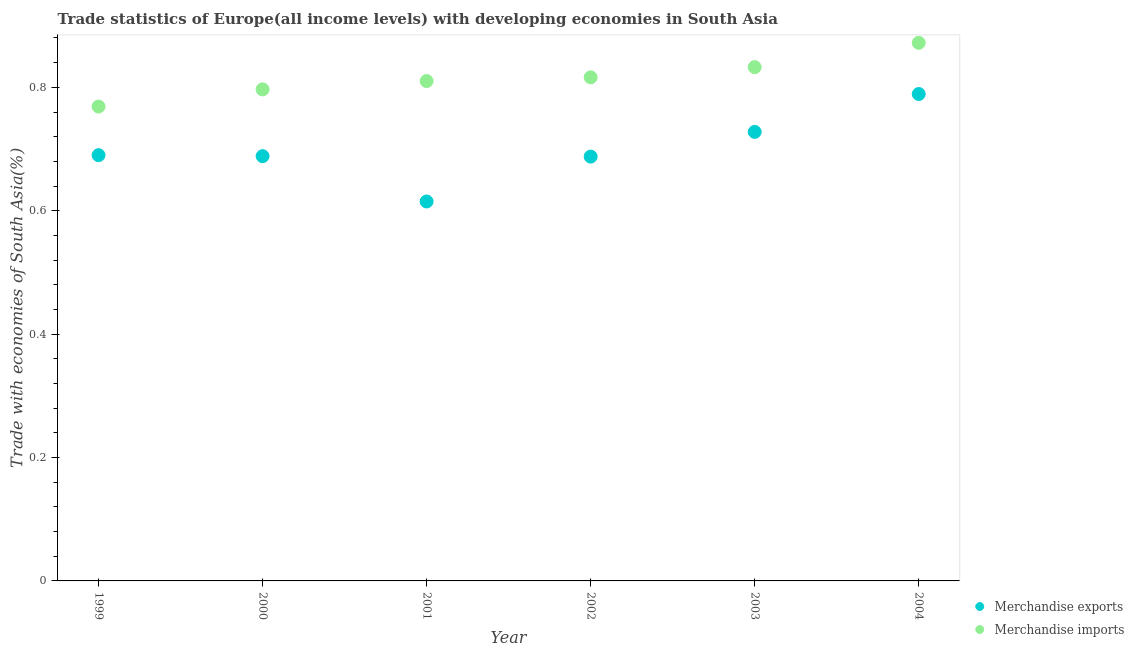How many different coloured dotlines are there?
Your response must be concise. 2. Is the number of dotlines equal to the number of legend labels?
Offer a very short reply. Yes. What is the merchandise imports in 2002?
Give a very brief answer. 0.82. Across all years, what is the maximum merchandise exports?
Offer a very short reply. 0.79. Across all years, what is the minimum merchandise imports?
Offer a very short reply. 0.77. In which year was the merchandise exports minimum?
Provide a short and direct response. 2001. What is the total merchandise exports in the graph?
Offer a terse response. 4.2. What is the difference between the merchandise imports in 1999 and that in 2004?
Make the answer very short. -0.1. What is the difference between the merchandise imports in 2002 and the merchandise exports in 2004?
Provide a succinct answer. 0.03. What is the average merchandise exports per year?
Make the answer very short. 0.7. In the year 2001, what is the difference between the merchandise imports and merchandise exports?
Give a very brief answer. 0.2. In how many years, is the merchandise imports greater than 0.12 %?
Provide a succinct answer. 6. What is the ratio of the merchandise imports in 2000 to that in 2001?
Provide a short and direct response. 0.98. Is the merchandise imports in 2000 less than that in 2003?
Make the answer very short. Yes. Is the difference between the merchandise exports in 1999 and 2003 greater than the difference between the merchandise imports in 1999 and 2003?
Keep it short and to the point. Yes. What is the difference between the highest and the second highest merchandise imports?
Your answer should be very brief. 0.04. What is the difference between the highest and the lowest merchandise exports?
Your answer should be very brief. 0.17. Is the sum of the merchandise exports in 1999 and 2001 greater than the maximum merchandise imports across all years?
Your response must be concise. Yes. Does the merchandise imports monotonically increase over the years?
Provide a short and direct response. Yes. How many years are there in the graph?
Your response must be concise. 6. Are the values on the major ticks of Y-axis written in scientific E-notation?
Your answer should be very brief. No. Does the graph contain any zero values?
Your answer should be compact. No. Does the graph contain grids?
Offer a terse response. No. How are the legend labels stacked?
Provide a succinct answer. Vertical. What is the title of the graph?
Offer a terse response. Trade statistics of Europe(all income levels) with developing economies in South Asia. Does "Boys" appear as one of the legend labels in the graph?
Keep it short and to the point. No. What is the label or title of the Y-axis?
Keep it short and to the point. Trade with economies of South Asia(%). What is the Trade with economies of South Asia(%) of Merchandise exports in 1999?
Provide a succinct answer. 0.69. What is the Trade with economies of South Asia(%) in Merchandise imports in 1999?
Make the answer very short. 0.77. What is the Trade with economies of South Asia(%) of Merchandise exports in 2000?
Give a very brief answer. 0.69. What is the Trade with economies of South Asia(%) in Merchandise imports in 2000?
Provide a short and direct response. 0.8. What is the Trade with economies of South Asia(%) in Merchandise exports in 2001?
Provide a short and direct response. 0.61. What is the Trade with economies of South Asia(%) of Merchandise imports in 2001?
Ensure brevity in your answer.  0.81. What is the Trade with economies of South Asia(%) of Merchandise exports in 2002?
Keep it short and to the point. 0.69. What is the Trade with economies of South Asia(%) of Merchandise imports in 2002?
Make the answer very short. 0.82. What is the Trade with economies of South Asia(%) in Merchandise exports in 2003?
Keep it short and to the point. 0.73. What is the Trade with economies of South Asia(%) of Merchandise imports in 2003?
Offer a terse response. 0.83. What is the Trade with economies of South Asia(%) in Merchandise exports in 2004?
Provide a succinct answer. 0.79. What is the Trade with economies of South Asia(%) in Merchandise imports in 2004?
Offer a very short reply. 0.87. Across all years, what is the maximum Trade with economies of South Asia(%) of Merchandise exports?
Make the answer very short. 0.79. Across all years, what is the maximum Trade with economies of South Asia(%) in Merchandise imports?
Your response must be concise. 0.87. Across all years, what is the minimum Trade with economies of South Asia(%) of Merchandise exports?
Make the answer very short. 0.61. Across all years, what is the minimum Trade with economies of South Asia(%) in Merchandise imports?
Offer a very short reply. 0.77. What is the total Trade with economies of South Asia(%) of Merchandise exports in the graph?
Your answer should be very brief. 4.2. What is the total Trade with economies of South Asia(%) in Merchandise imports in the graph?
Provide a short and direct response. 4.9. What is the difference between the Trade with economies of South Asia(%) of Merchandise exports in 1999 and that in 2000?
Keep it short and to the point. 0. What is the difference between the Trade with economies of South Asia(%) of Merchandise imports in 1999 and that in 2000?
Provide a succinct answer. -0.03. What is the difference between the Trade with economies of South Asia(%) of Merchandise exports in 1999 and that in 2001?
Give a very brief answer. 0.08. What is the difference between the Trade with economies of South Asia(%) of Merchandise imports in 1999 and that in 2001?
Offer a very short reply. -0.04. What is the difference between the Trade with economies of South Asia(%) in Merchandise exports in 1999 and that in 2002?
Provide a short and direct response. 0. What is the difference between the Trade with economies of South Asia(%) of Merchandise imports in 1999 and that in 2002?
Offer a terse response. -0.05. What is the difference between the Trade with economies of South Asia(%) of Merchandise exports in 1999 and that in 2003?
Keep it short and to the point. -0.04. What is the difference between the Trade with economies of South Asia(%) of Merchandise imports in 1999 and that in 2003?
Provide a succinct answer. -0.06. What is the difference between the Trade with economies of South Asia(%) in Merchandise exports in 1999 and that in 2004?
Your response must be concise. -0.1. What is the difference between the Trade with economies of South Asia(%) in Merchandise imports in 1999 and that in 2004?
Your response must be concise. -0.1. What is the difference between the Trade with economies of South Asia(%) in Merchandise exports in 2000 and that in 2001?
Make the answer very short. 0.07. What is the difference between the Trade with economies of South Asia(%) in Merchandise imports in 2000 and that in 2001?
Make the answer very short. -0.01. What is the difference between the Trade with economies of South Asia(%) of Merchandise exports in 2000 and that in 2002?
Make the answer very short. 0. What is the difference between the Trade with economies of South Asia(%) in Merchandise imports in 2000 and that in 2002?
Offer a very short reply. -0.02. What is the difference between the Trade with economies of South Asia(%) of Merchandise exports in 2000 and that in 2003?
Your response must be concise. -0.04. What is the difference between the Trade with economies of South Asia(%) in Merchandise imports in 2000 and that in 2003?
Provide a succinct answer. -0.04. What is the difference between the Trade with economies of South Asia(%) of Merchandise exports in 2000 and that in 2004?
Keep it short and to the point. -0.1. What is the difference between the Trade with economies of South Asia(%) in Merchandise imports in 2000 and that in 2004?
Offer a very short reply. -0.08. What is the difference between the Trade with economies of South Asia(%) in Merchandise exports in 2001 and that in 2002?
Provide a succinct answer. -0.07. What is the difference between the Trade with economies of South Asia(%) of Merchandise imports in 2001 and that in 2002?
Ensure brevity in your answer.  -0.01. What is the difference between the Trade with economies of South Asia(%) of Merchandise exports in 2001 and that in 2003?
Offer a terse response. -0.11. What is the difference between the Trade with economies of South Asia(%) of Merchandise imports in 2001 and that in 2003?
Your answer should be very brief. -0.02. What is the difference between the Trade with economies of South Asia(%) in Merchandise exports in 2001 and that in 2004?
Keep it short and to the point. -0.17. What is the difference between the Trade with economies of South Asia(%) of Merchandise imports in 2001 and that in 2004?
Keep it short and to the point. -0.06. What is the difference between the Trade with economies of South Asia(%) of Merchandise exports in 2002 and that in 2003?
Make the answer very short. -0.04. What is the difference between the Trade with economies of South Asia(%) of Merchandise imports in 2002 and that in 2003?
Provide a succinct answer. -0.02. What is the difference between the Trade with economies of South Asia(%) in Merchandise exports in 2002 and that in 2004?
Make the answer very short. -0.1. What is the difference between the Trade with economies of South Asia(%) in Merchandise imports in 2002 and that in 2004?
Your response must be concise. -0.06. What is the difference between the Trade with economies of South Asia(%) in Merchandise exports in 2003 and that in 2004?
Make the answer very short. -0.06. What is the difference between the Trade with economies of South Asia(%) in Merchandise imports in 2003 and that in 2004?
Your answer should be very brief. -0.04. What is the difference between the Trade with economies of South Asia(%) of Merchandise exports in 1999 and the Trade with economies of South Asia(%) of Merchandise imports in 2000?
Your answer should be very brief. -0.11. What is the difference between the Trade with economies of South Asia(%) in Merchandise exports in 1999 and the Trade with economies of South Asia(%) in Merchandise imports in 2001?
Provide a short and direct response. -0.12. What is the difference between the Trade with economies of South Asia(%) of Merchandise exports in 1999 and the Trade with economies of South Asia(%) of Merchandise imports in 2002?
Provide a short and direct response. -0.13. What is the difference between the Trade with economies of South Asia(%) of Merchandise exports in 1999 and the Trade with economies of South Asia(%) of Merchandise imports in 2003?
Offer a very short reply. -0.14. What is the difference between the Trade with economies of South Asia(%) in Merchandise exports in 1999 and the Trade with economies of South Asia(%) in Merchandise imports in 2004?
Make the answer very short. -0.18. What is the difference between the Trade with economies of South Asia(%) of Merchandise exports in 2000 and the Trade with economies of South Asia(%) of Merchandise imports in 2001?
Offer a terse response. -0.12. What is the difference between the Trade with economies of South Asia(%) in Merchandise exports in 2000 and the Trade with economies of South Asia(%) in Merchandise imports in 2002?
Offer a terse response. -0.13. What is the difference between the Trade with economies of South Asia(%) in Merchandise exports in 2000 and the Trade with economies of South Asia(%) in Merchandise imports in 2003?
Offer a very short reply. -0.14. What is the difference between the Trade with economies of South Asia(%) in Merchandise exports in 2000 and the Trade with economies of South Asia(%) in Merchandise imports in 2004?
Ensure brevity in your answer.  -0.18. What is the difference between the Trade with economies of South Asia(%) of Merchandise exports in 2001 and the Trade with economies of South Asia(%) of Merchandise imports in 2002?
Provide a short and direct response. -0.2. What is the difference between the Trade with economies of South Asia(%) of Merchandise exports in 2001 and the Trade with economies of South Asia(%) of Merchandise imports in 2003?
Offer a very short reply. -0.22. What is the difference between the Trade with economies of South Asia(%) of Merchandise exports in 2001 and the Trade with economies of South Asia(%) of Merchandise imports in 2004?
Your answer should be compact. -0.26. What is the difference between the Trade with economies of South Asia(%) of Merchandise exports in 2002 and the Trade with economies of South Asia(%) of Merchandise imports in 2003?
Your answer should be very brief. -0.14. What is the difference between the Trade with economies of South Asia(%) of Merchandise exports in 2002 and the Trade with economies of South Asia(%) of Merchandise imports in 2004?
Make the answer very short. -0.18. What is the difference between the Trade with economies of South Asia(%) in Merchandise exports in 2003 and the Trade with economies of South Asia(%) in Merchandise imports in 2004?
Offer a terse response. -0.14. What is the average Trade with economies of South Asia(%) of Merchandise exports per year?
Give a very brief answer. 0.7. What is the average Trade with economies of South Asia(%) in Merchandise imports per year?
Offer a very short reply. 0.82. In the year 1999, what is the difference between the Trade with economies of South Asia(%) of Merchandise exports and Trade with economies of South Asia(%) of Merchandise imports?
Ensure brevity in your answer.  -0.08. In the year 2000, what is the difference between the Trade with economies of South Asia(%) of Merchandise exports and Trade with economies of South Asia(%) of Merchandise imports?
Your response must be concise. -0.11. In the year 2001, what is the difference between the Trade with economies of South Asia(%) in Merchandise exports and Trade with economies of South Asia(%) in Merchandise imports?
Your answer should be compact. -0.2. In the year 2002, what is the difference between the Trade with economies of South Asia(%) of Merchandise exports and Trade with economies of South Asia(%) of Merchandise imports?
Offer a very short reply. -0.13. In the year 2003, what is the difference between the Trade with economies of South Asia(%) of Merchandise exports and Trade with economies of South Asia(%) of Merchandise imports?
Offer a terse response. -0.1. In the year 2004, what is the difference between the Trade with economies of South Asia(%) of Merchandise exports and Trade with economies of South Asia(%) of Merchandise imports?
Give a very brief answer. -0.08. What is the ratio of the Trade with economies of South Asia(%) of Merchandise imports in 1999 to that in 2000?
Provide a short and direct response. 0.97. What is the ratio of the Trade with economies of South Asia(%) in Merchandise exports in 1999 to that in 2001?
Ensure brevity in your answer.  1.12. What is the ratio of the Trade with economies of South Asia(%) of Merchandise imports in 1999 to that in 2001?
Offer a terse response. 0.95. What is the ratio of the Trade with economies of South Asia(%) in Merchandise imports in 1999 to that in 2002?
Your response must be concise. 0.94. What is the ratio of the Trade with economies of South Asia(%) of Merchandise exports in 1999 to that in 2003?
Your response must be concise. 0.95. What is the ratio of the Trade with economies of South Asia(%) of Merchandise imports in 1999 to that in 2003?
Make the answer very short. 0.92. What is the ratio of the Trade with economies of South Asia(%) of Merchandise exports in 1999 to that in 2004?
Provide a succinct answer. 0.87. What is the ratio of the Trade with economies of South Asia(%) of Merchandise imports in 1999 to that in 2004?
Provide a succinct answer. 0.88. What is the ratio of the Trade with economies of South Asia(%) of Merchandise exports in 2000 to that in 2001?
Your answer should be compact. 1.12. What is the ratio of the Trade with economies of South Asia(%) of Merchandise imports in 2000 to that in 2001?
Keep it short and to the point. 0.98. What is the ratio of the Trade with economies of South Asia(%) in Merchandise exports in 2000 to that in 2002?
Your response must be concise. 1. What is the ratio of the Trade with economies of South Asia(%) of Merchandise imports in 2000 to that in 2002?
Your response must be concise. 0.98. What is the ratio of the Trade with economies of South Asia(%) of Merchandise exports in 2000 to that in 2003?
Offer a very short reply. 0.95. What is the ratio of the Trade with economies of South Asia(%) of Merchandise imports in 2000 to that in 2003?
Your response must be concise. 0.96. What is the ratio of the Trade with economies of South Asia(%) of Merchandise exports in 2000 to that in 2004?
Your answer should be very brief. 0.87. What is the ratio of the Trade with economies of South Asia(%) of Merchandise imports in 2000 to that in 2004?
Provide a succinct answer. 0.91. What is the ratio of the Trade with economies of South Asia(%) in Merchandise exports in 2001 to that in 2002?
Provide a succinct answer. 0.89. What is the ratio of the Trade with economies of South Asia(%) of Merchandise exports in 2001 to that in 2003?
Offer a very short reply. 0.85. What is the ratio of the Trade with economies of South Asia(%) of Merchandise imports in 2001 to that in 2003?
Keep it short and to the point. 0.97. What is the ratio of the Trade with economies of South Asia(%) of Merchandise exports in 2001 to that in 2004?
Make the answer very short. 0.78. What is the ratio of the Trade with economies of South Asia(%) in Merchandise imports in 2001 to that in 2004?
Make the answer very short. 0.93. What is the ratio of the Trade with economies of South Asia(%) of Merchandise exports in 2002 to that in 2003?
Give a very brief answer. 0.94. What is the ratio of the Trade with economies of South Asia(%) in Merchandise imports in 2002 to that in 2003?
Provide a succinct answer. 0.98. What is the ratio of the Trade with economies of South Asia(%) of Merchandise exports in 2002 to that in 2004?
Give a very brief answer. 0.87. What is the ratio of the Trade with economies of South Asia(%) in Merchandise imports in 2002 to that in 2004?
Provide a short and direct response. 0.94. What is the ratio of the Trade with economies of South Asia(%) of Merchandise exports in 2003 to that in 2004?
Offer a very short reply. 0.92. What is the ratio of the Trade with economies of South Asia(%) in Merchandise imports in 2003 to that in 2004?
Provide a short and direct response. 0.95. What is the difference between the highest and the second highest Trade with economies of South Asia(%) of Merchandise exports?
Give a very brief answer. 0.06. What is the difference between the highest and the second highest Trade with economies of South Asia(%) of Merchandise imports?
Provide a succinct answer. 0.04. What is the difference between the highest and the lowest Trade with economies of South Asia(%) in Merchandise exports?
Give a very brief answer. 0.17. What is the difference between the highest and the lowest Trade with economies of South Asia(%) in Merchandise imports?
Your response must be concise. 0.1. 